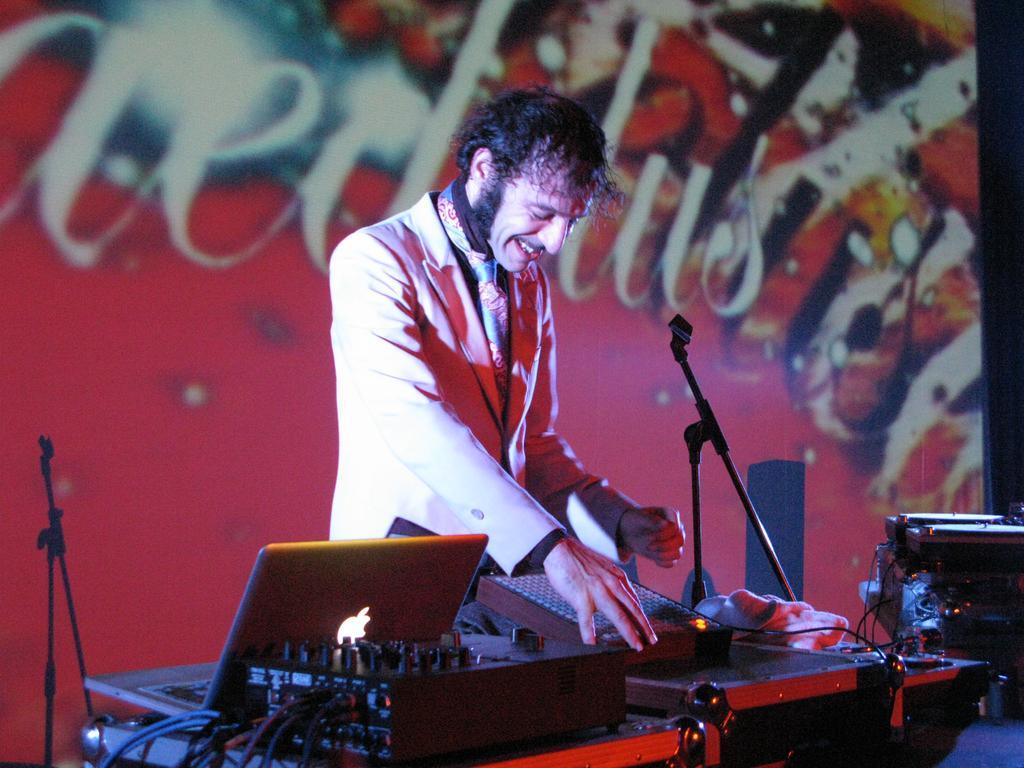How would you summarize this image in a sentence or two? In this image in the center there is one person who is standing and he is smiling, in front of him there are some musical instruments, wires and a laptop cloth and in the background there is a wall. On the wall there is some text. 